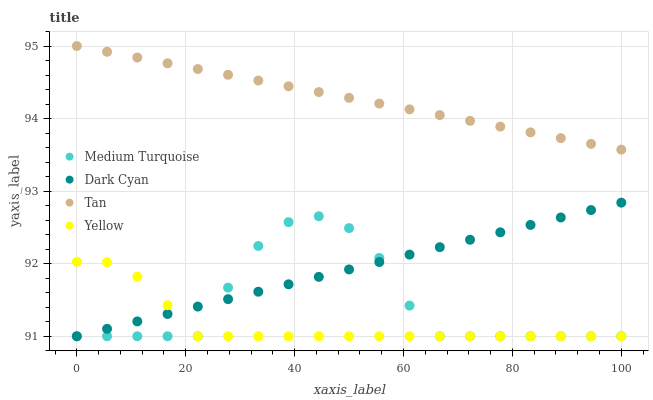Does Yellow have the minimum area under the curve?
Answer yes or no. Yes. Does Tan have the maximum area under the curve?
Answer yes or no. Yes. Does Tan have the minimum area under the curve?
Answer yes or no. No. Does Yellow have the maximum area under the curve?
Answer yes or no. No. Is Tan the smoothest?
Answer yes or no. Yes. Is Medium Turquoise the roughest?
Answer yes or no. Yes. Is Yellow the smoothest?
Answer yes or no. No. Is Yellow the roughest?
Answer yes or no. No. Does Dark Cyan have the lowest value?
Answer yes or no. Yes. Does Tan have the lowest value?
Answer yes or no. No. Does Tan have the highest value?
Answer yes or no. Yes. Does Yellow have the highest value?
Answer yes or no. No. Is Medium Turquoise less than Tan?
Answer yes or no. Yes. Is Tan greater than Medium Turquoise?
Answer yes or no. Yes. Does Yellow intersect Dark Cyan?
Answer yes or no. Yes. Is Yellow less than Dark Cyan?
Answer yes or no. No. Is Yellow greater than Dark Cyan?
Answer yes or no. No. Does Medium Turquoise intersect Tan?
Answer yes or no. No. 